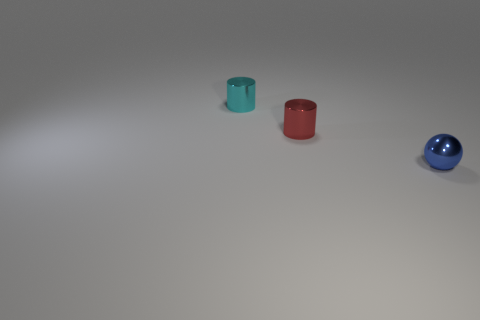Are there fewer cyan metallic objects to the right of the blue ball than tiny metallic balls on the right side of the tiny cyan object?
Your answer should be very brief. Yes. How many objects are either tiny blue balls or cyan cylinders?
Your answer should be compact. 2. There is a small red metallic object; what number of red metallic objects are behind it?
Provide a short and direct response. 0. What is the shape of the small cyan object that is made of the same material as the sphere?
Your answer should be very brief. Cylinder. There is a shiny thing in front of the red metal thing; is it the same shape as the red thing?
Offer a very short reply. No. How many red objects are metallic spheres or cylinders?
Your answer should be compact. 1. Are there an equal number of metallic cylinders behind the small red metal cylinder and small shiny things that are behind the cyan metallic thing?
Ensure brevity in your answer.  No. The tiny metal thing behind the shiny cylinder that is right of the tiny metal cylinder behind the red metal thing is what color?
Provide a succinct answer. Cyan. Are there any other things that are the same color as the ball?
Your answer should be compact. No. What is the size of the cylinder in front of the cyan object?
Keep it short and to the point. Small. 